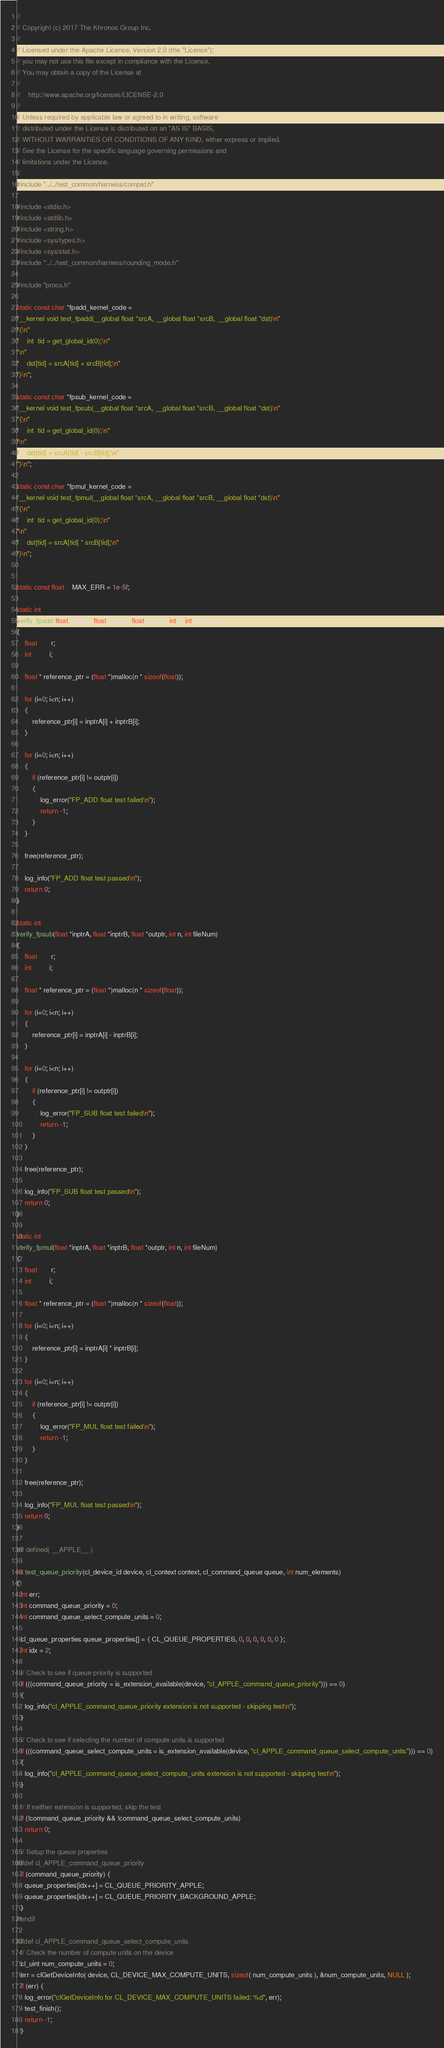<code> <loc_0><loc_0><loc_500><loc_500><_C_>//
// Copyright (c) 2017 The Khronos Group Inc.
// 
// Licensed under the Apache License, Version 2.0 (the "License");
// you may not use this file except in compliance with the License.
// You may obtain a copy of the License at
//
//    http://www.apache.org/licenses/LICENSE-2.0
//
// Unless required by applicable law or agreed to in writing, software
// distributed under the License is distributed on an "AS IS" BASIS,
// WITHOUT WARRANTIES OR CONDITIONS OF ANY KIND, either express or implied.
// See the License for the specific language governing permissions and
// limitations under the License.
//
#include "../../test_common/harness/compat.h"

#include <stdio.h>
#include <stdlib.h>
#include <string.h>
#include <sys/types.h>
#include <sys/stat.h>
#include "../../test_common/harness/rounding_mode.h"

#include "procs.h"

static const char *fpadd_kernel_code =
"__kernel void test_fpadd(__global float *srcA, __global float *srcB, __global float *dst)\n"
"{\n"
"    int  tid = get_global_id(0);\n"
"\n"
"    dst[tid] = srcA[tid] + srcB[tid];\n"
"}\n";

static const char *fpsub_kernel_code =
"__kernel void test_fpsub(__global float *srcA, __global float *srcB, __global float *dst)\n"
"{\n"
"    int  tid = get_global_id(0);\n"
"\n"
"    dst[tid] = srcA[tid] - srcB[tid];\n"
"}\n";

static const char *fpmul_kernel_code =
"__kernel void test_fpmul(__global float *srcA, __global float *srcB, __global float *dst)\n"
"{\n"
"    int  tid = get_global_id(0);\n"
"\n"
"    dst[tid] = srcA[tid] * srcB[tid];\n"
"}\n";


static const float    MAX_ERR = 1e-5f;

static int
verify_fpadd(float *inptrA, float *inptrB, float *outptr, int n, int fileNum)
{
    float       r;
    int         i;

    float * reference_ptr = (float *)malloc(n * sizeof(float));

    for (i=0; i<n; i++)
    {
        reference_ptr[i] = inptrA[i] + inptrB[i];
    }

    for (i=0; i<n; i++)
    {
        if (reference_ptr[i] != outptr[i])
        {
            log_error("FP_ADD float test failed\n");
            return -1;
        }
    }

    free(reference_ptr);

    log_info("FP_ADD float test passed\n");
    return 0;
}

static int
verify_fpsub(float *inptrA, float *inptrB, float *outptr, int n, int fileNum)
{
    float       r;
    int         i;

    float * reference_ptr = (float *)malloc(n * sizeof(float));

    for (i=0; i<n; i++)
    {
        reference_ptr[i] = inptrA[i] - inptrB[i];
    }

    for (i=0; i<n; i++)
    {
        if (reference_ptr[i] != outptr[i])
        {
            log_error("FP_SUB float test failed\n");
            return -1;
        }
    }

    free(reference_ptr);

    log_info("FP_SUB float test passed\n");
    return 0;
}

static int
verify_fpmul(float *inptrA, float *inptrB, float *outptr, int n, int fileNum)
{
    float       r;
    int         i;

    float * reference_ptr = (float *)malloc(n * sizeof(float));

    for (i=0; i<n; i++)
    {
        reference_ptr[i] = inptrA[i] * inptrB[i];
    }

    for (i=0; i<n; i++)
    {
        if (reference_ptr[i] != outptr[i])
        {
            log_error("FP_MUL float test failed\n");
            return -1;
        }
    }

    free(reference_ptr);

    log_info("FP_MUL float test passed\n");
    return 0;
}

#if defined( __APPLE__ )

int test_queue_priority(cl_device_id device, cl_context context, cl_command_queue queue, int num_elements)
{
  int err;
  int command_queue_priority = 0;
  int command_queue_select_compute_units = 0;

  cl_queue_properties queue_properties[] = { CL_QUEUE_PROPERTIES, 0, 0, 0, 0, 0, 0 };
  int idx = 2;

  // Check to see if queue priority is supported
  if (((command_queue_priority = is_extension_available(device, "cl_APPLE_command_queue_priority"))) == 0)
  {
    log_info("cl_APPLE_command_queue_priority extension is not supported - skipping test\n");
  }

  // Check to see if selecting the number of compute units is supported
  if (((command_queue_select_compute_units = is_extension_available(device, "cl_APPLE_command_queue_select_compute_units"))) == 0)
  {
    log_info("cl_APPLE_command_queue_select_compute_units extension is not supported - skipping test\n");
  }

  // If neither extension is supported, skip the test
  if (!command_queue_priority && !command_queue_select_compute_units)
    return 0;

  // Setup the queue properties
#ifdef cl_APPLE_command_queue_priority
  if (command_queue_priority) {
    queue_properties[idx++] = CL_QUEUE_PRIORITY_APPLE;
    queue_properties[idx++] = CL_QUEUE_PRIORITY_BACKGROUND_APPLE;
  }
#endif

#ifdef cl_APPLE_command_queue_select_compute_units
  // Check the number of compute units on the device
  cl_uint num_compute_units = 0;
  err = clGetDeviceInfo( device, CL_DEVICE_MAX_COMPUTE_UNITS, sizeof( num_compute_units ), &num_compute_units, NULL );
  if (err) {
    log_error("clGetDeviceInfo for CL_DEVICE_MAX_COMPUTE_UNITS failed: %d", err);
    test_finish();
    return -1;
  }
</code> 